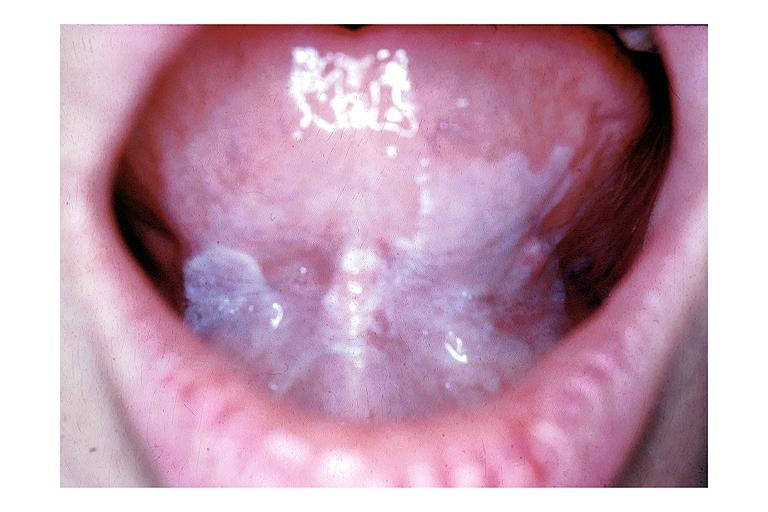what is present?
Answer the question using a single word or phrase. Oral 